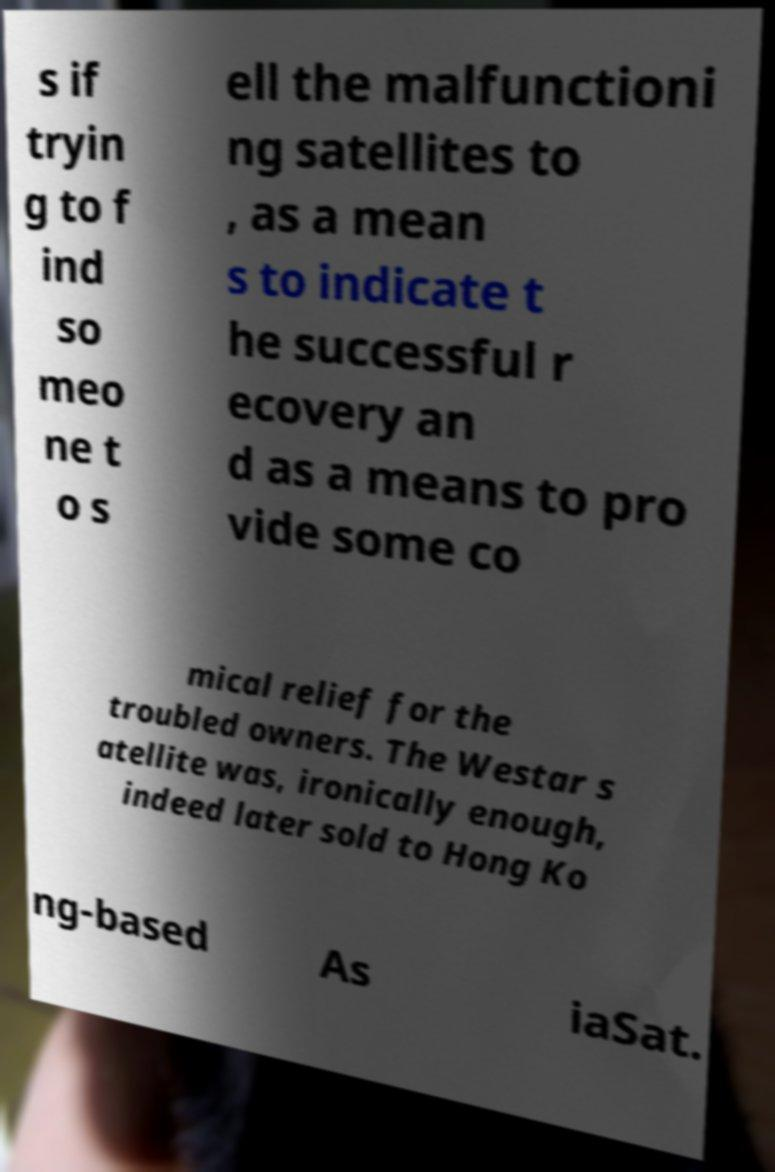Please identify and transcribe the text found in this image. s if tryin g to f ind so meo ne t o s ell the malfunctioni ng satellites to , as a mean s to indicate t he successful r ecovery an d as a means to pro vide some co mical relief for the troubled owners. The Westar s atellite was, ironically enough, indeed later sold to Hong Ko ng-based As iaSat. 